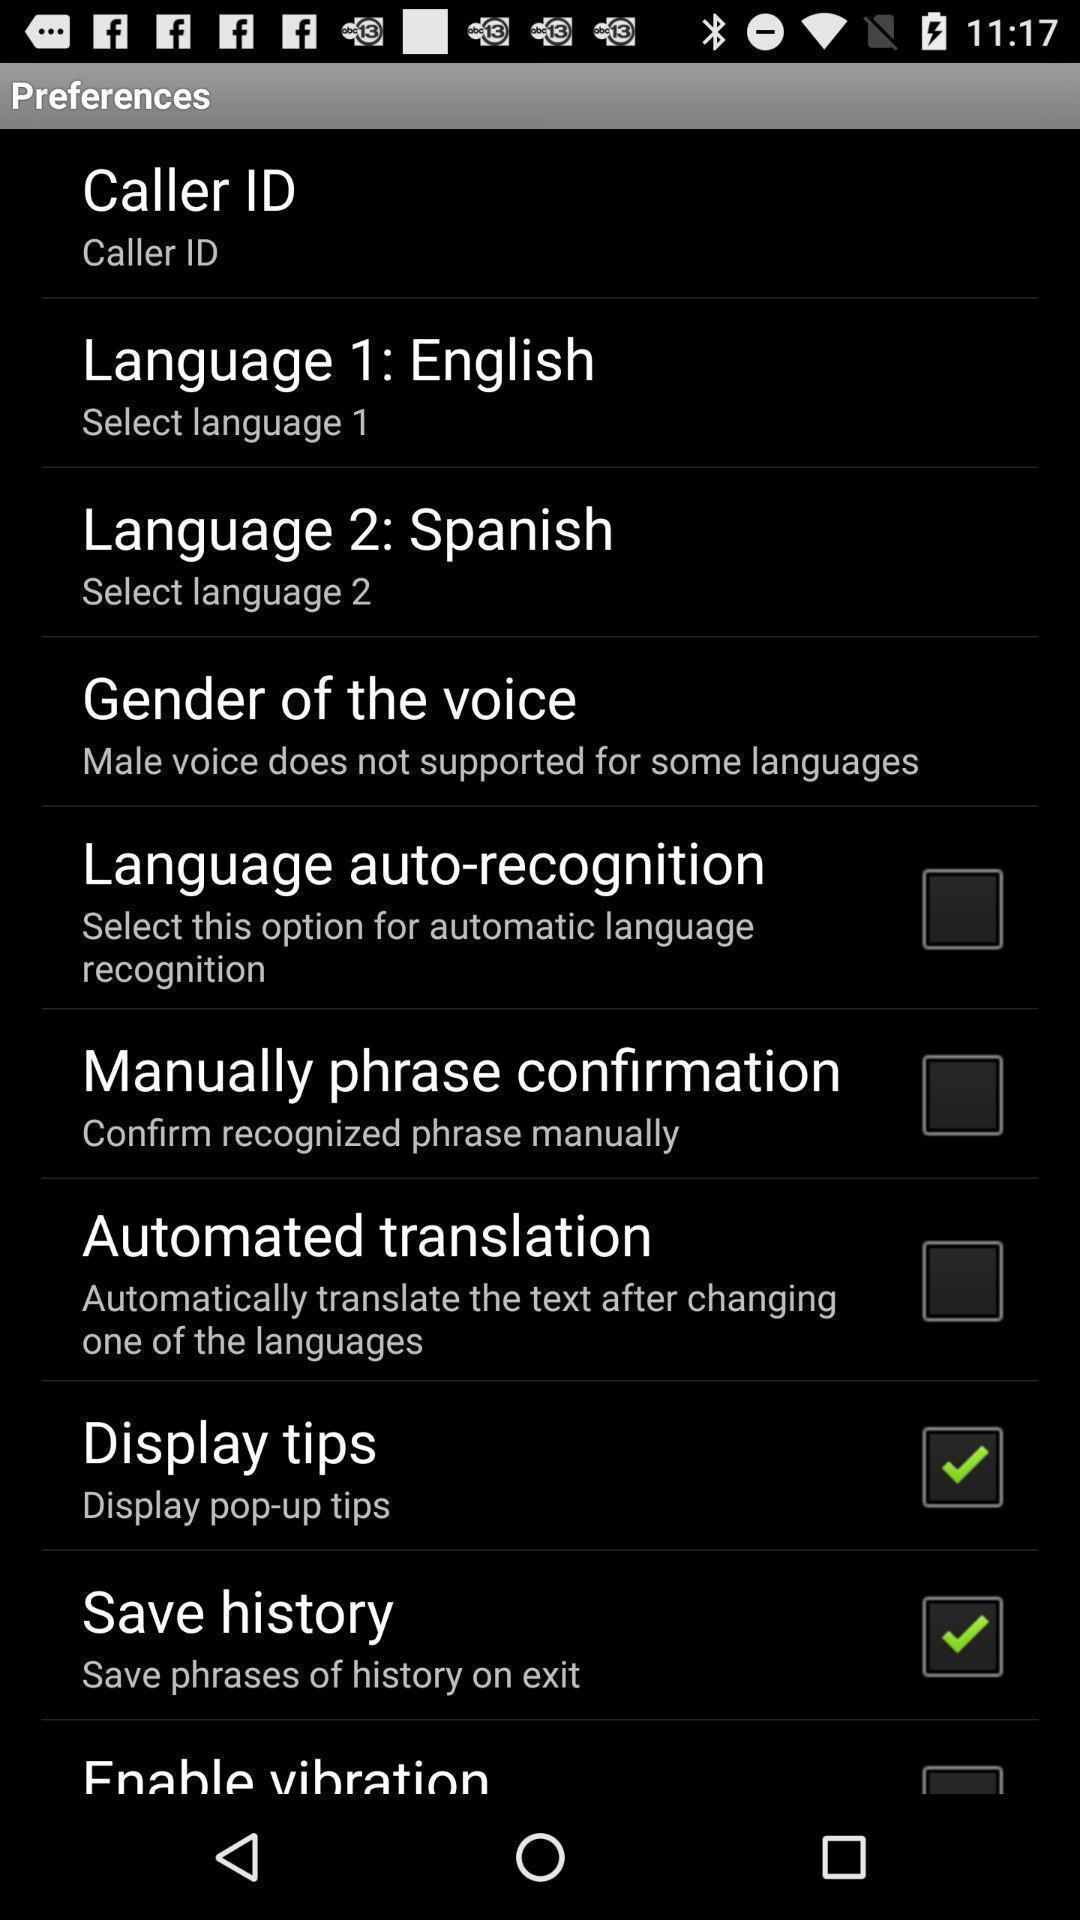Provide a detailed account of this screenshot. Various preferences displayed. 